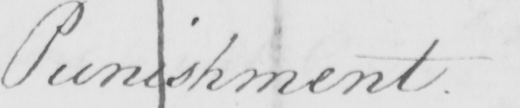Can you read and transcribe this handwriting? Punishment 